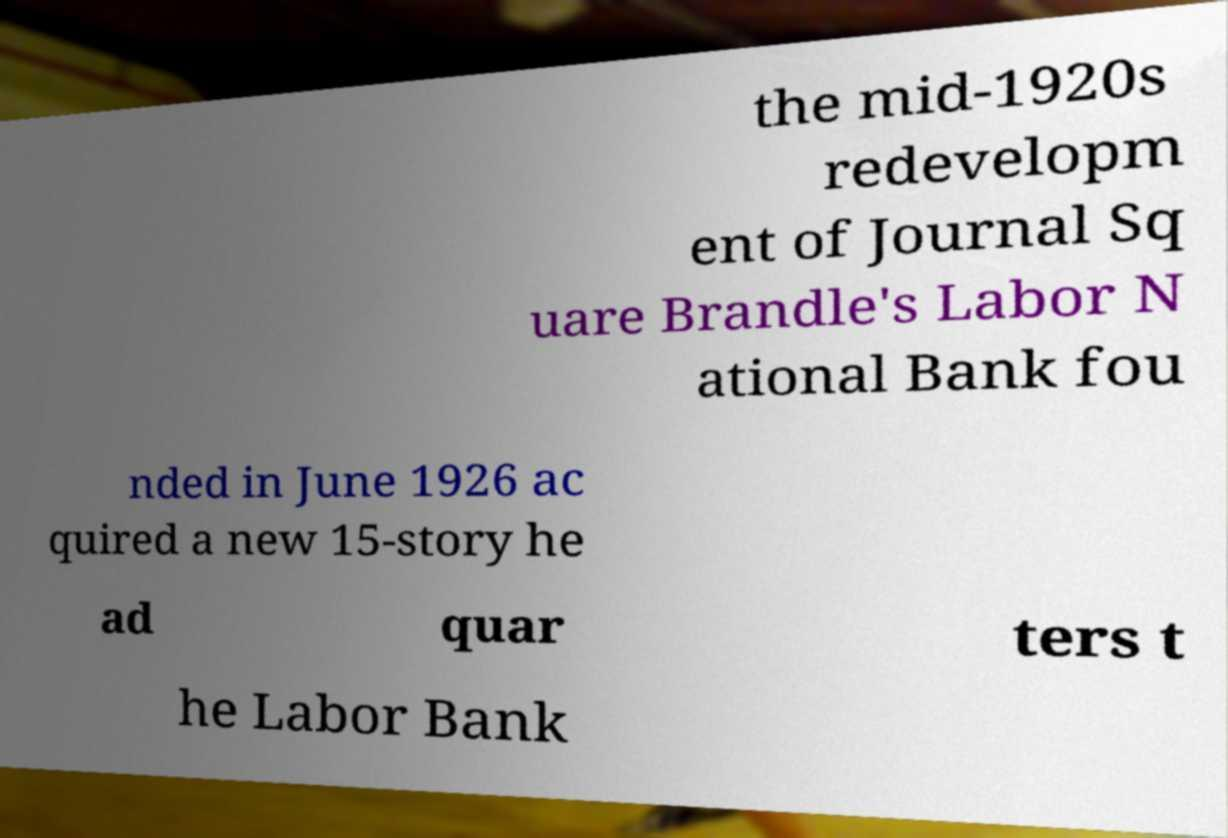Could you extract and type out the text from this image? the mid-1920s redevelopm ent of Journal Sq uare Brandle's Labor N ational Bank fou nded in June 1926 ac quired a new 15-story he ad quar ters t he Labor Bank 